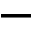Convert formula to latex. <formula><loc_0><loc_0><loc_500><loc_500>-</formula> 